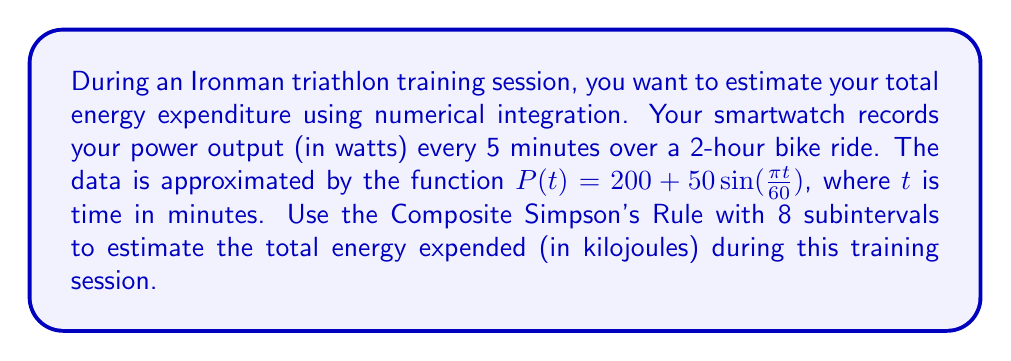Give your solution to this math problem. To solve this problem, we'll follow these steps:

1) The Composite Simpson's Rule for n subintervals is given by:

   $$\int_{a}^{b} f(x)dx \approx \frac{h}{3}\left[f(x_0) + 4f(x_1) + 2f(x_2) + 4f(x_3) + ... + 2f(x_{n-2}) + 4f(x_{n-1}) + f(x_n)\right]$$

   where $h = \frac{b-a}{n}$ and $x_i = a + ih$ for $i = 0, 1, ..., n$

2) In our case:
   $a = 0$, $b = 120$ (2 hours = 120 minutes), $n = 8$

3) Calculate $h$:
   $h = \frac{120 - 0}{8} = 15$ minutes

4) Calculate $x_i$ values:
   $x_0 = 0$, $x_1 = 15$, $x_2 = 30$, ..., $x_7 = 105$, $x_8 = 120$

5) Evaluate $P(t)$ at each $x_i$:
   $P(0) = 200$
   $P(15) = 200 + 50\sin(\frac{\pi 15}{60}) = 250$
   $P(30) = 200 + 50\sin(\frac{\pi 30}{60}) = 250$
   $P(45) = 200 + 50\sin(\frac{\pi 45}{60}) \approx 235.36$
   $P(60) = 200 + 50\sin(\frac{\pi 60}{60}) = 200$
   $P(75) = 200 + 50\sin(\frac{\pi 75}{60}) \approx 164.64$
   $P(90) = 200 + 50\sin(\frac{\pi 90}{60}) = 150$
   $P(105) = 200 + 50\sin(\frac{\pi 105}{60}) = 150$
   $P(120) = 200 + 50\sin(\frac{\pi 120}{60}) = 200$

6) Apply the Composite Simpson's Rule:

   $$\int_{0}^{120} P(t)dt \approx \frac{15}{3}[200 + 4(250) + 2(250) + 4(235.36) + 2(200) + 4(164.64) + 2(150) + 4(150) + 200]$$

7) Simplify:
   $$= 5[200 + 1000 + 500 + 941.44 + 400 + 658.56 + 300 + 600 + 200]$$
   $$= 5[4800]$$
   $$= 24000 \text{ watt-minutes}$$

8) Convert watt-minutes to kilojoules:
   $24000 \text{ watt-minutes} \times \frac{60 \text{ seconds}}{1 \text{ minute}} \times \frac{1 \text{ kilojoule}}{1000 \text{ watt-seconds}} = 1440 \text{ kilojoules}$

Therefore, the estimated total energy expenditure during the 2-hour bike ride is 1440 kilojoules.
Answer: 1440 kilojoules 